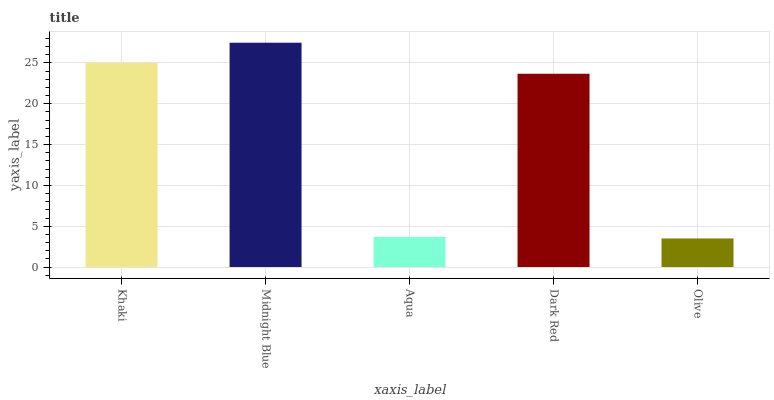Is Olive the minimum?
Answer yes or no. Yes. Is Midnight Blue the maximum?
Answer yes or no. Yes. Is Aqua the minimum?
Answer yes or no. No. Is Aqua the maximum?
Answer yes or no. No. Is Midnight Blue greater than Aqua?
Answer yes or no. Yes. Is Aqua less than Midnight Blue?
Answer yes or no. Yes. Is Aqua greater than Midnight Blue?
Answer yes or no. No. Is Midnight Blue less than Aqua?
Answer yes or no. No. Is Dark Red the high median?
Answer yes or no. Yes. Is Dark Red the low median?
Answer yes or no. Yes. Is Olive the high median?
Answer yes or no. No. Is Olive the low median?
Answer yes or no. No. 